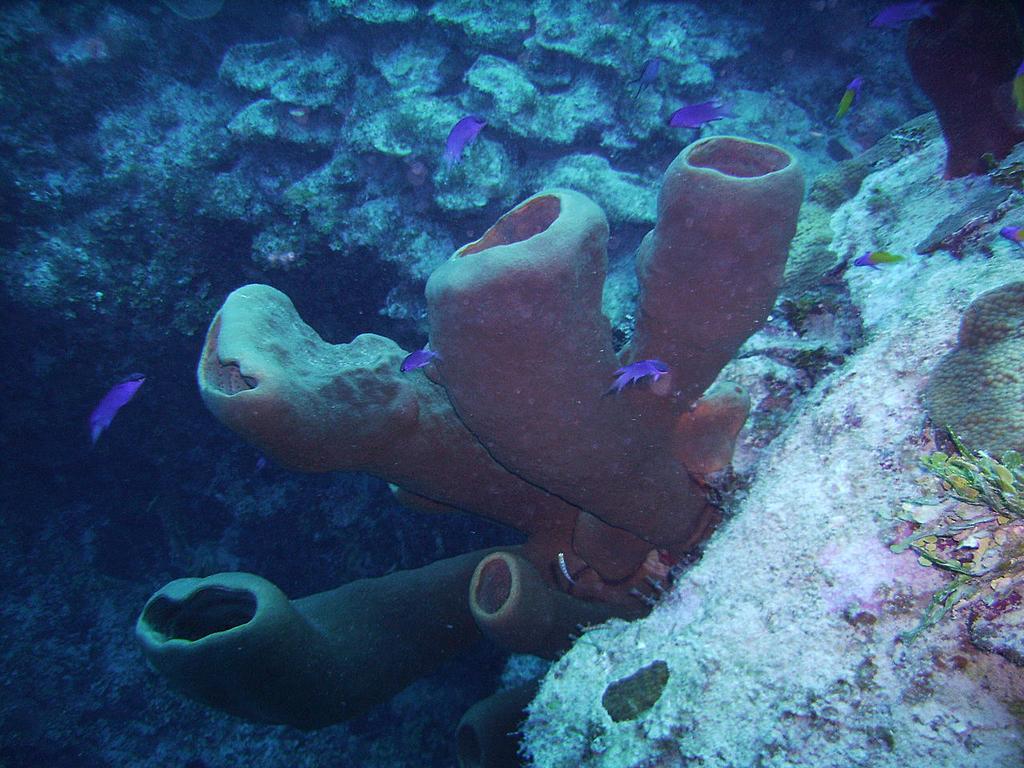Can you describe this image briefly? In the center of the image we can see plants, stones, fish and a few other objects in the water. 